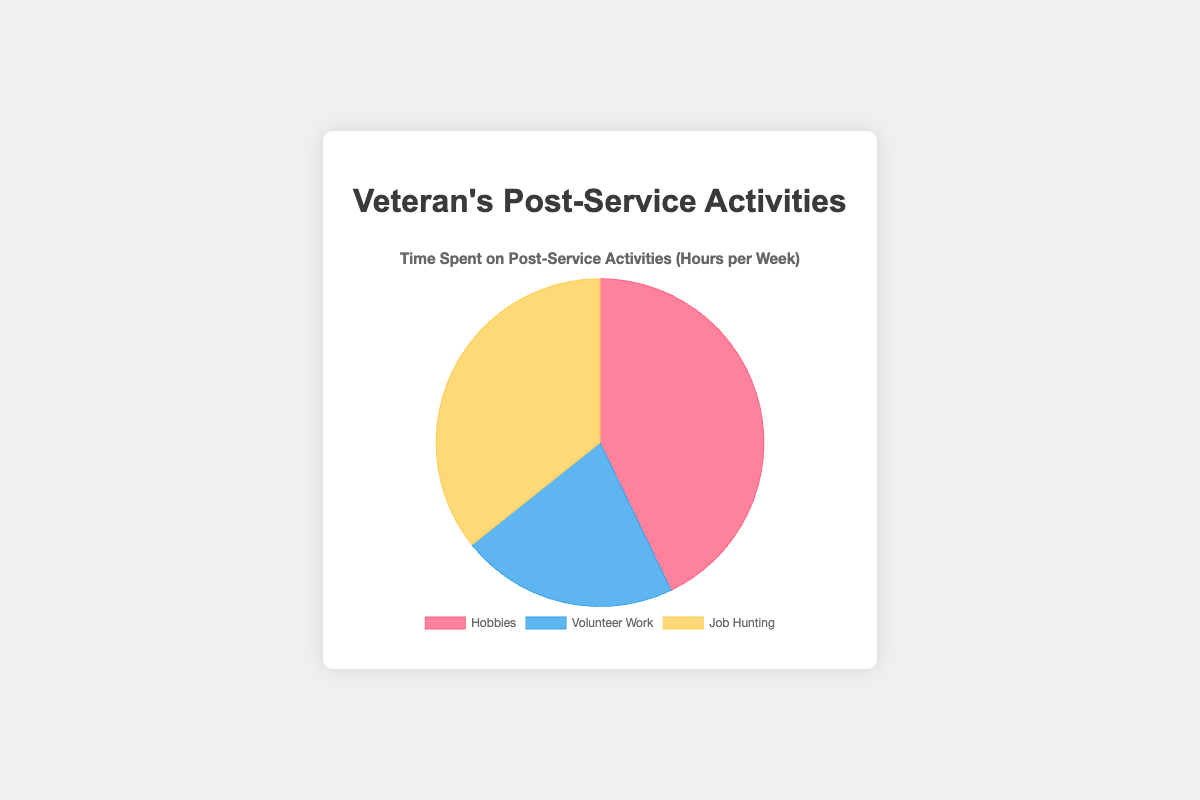Which activity takes up the largest portion of time for post-service activities? The pie chart divides the total time into three categories. The largest section corresponds to "Hobbies".
Answer: Hobbies What is the total amount of time spent on all activities per week? Add up the total hours for each activity shown in the pie chart: 12 hours (Hobbies) + 6 hours (Volunteer Work) + 10 hours (Job Hunting) = 28 hours.
Answer: 28 hours How does the time spent on Volunteer Work compare to Job Hunting? The pie chart shows 6 hours for Volunteer Work and 10 hours for Job Hunting. 10 is greater than 6, so more time is spent on Job Hunting.
Answer: Job Hunting takes more time What proportion of time is spent on Hobbies compared to the total time? Hobbies take up 12 hours out of the total 28 hours. Calculate the proportion: 12/28 = 0.4286, or approximately 43%.
Answer: Approximately 43% How many more hours are spent on Job Hunting compared to Volunteer Work? From the pie chart, Job Hunting is 10 hours and Volunteer Work is 6 hours. The difference is 10 - 6 = 4 hours.
Answer: 4 hours Which activity spends the least amount of time per week? The smallest section of the pie chart corresponds to Volunteer Work, which is 6 hours.
Answer: Volunteer Work What are the colors representing each of the activities in the pie chart? The categories are colored as follows: Hobbies (red), Volunteer Work (blue), Job Hunting (yellow).
Answer: Hobbies (red), Volunteer Work (blue), Job Hunting (yellow) What is the average time spent per week across all activities? Total time is 28 hours and there are 3 activities. Calculate the average: 28/3 = 9.33 hours.
Answer: 9.33 hours What percentage of total time is dedicated to Job Hunting? Job Hunting takes 10 hours. To find the percentage: (10/28) * 100 ≈ 35.71%.
Answer: Approximately 35.71% Is the time spent on Hobbies closer to the time spent on Volunteer Work or Job Hunting? Hobbies take 12 hours, Volunteer Work takes 6 hours, and Job Hunting takes 10 hours. The difference between Hobbies and Volunteer Work is 6 hours, while the difference between Hobbies and Job Hunting is 2 hours. Since 2 is less than 6, Hobbies is closer to Job Hunting.
Answer: Closer to Job Hunting 